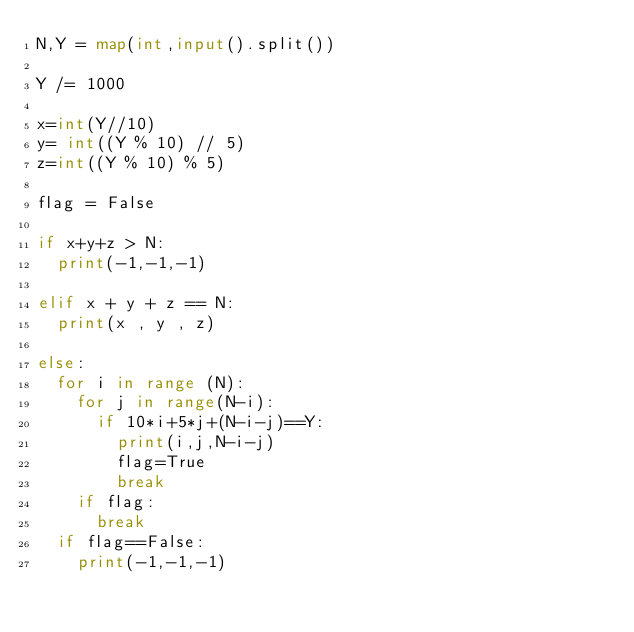Convert code to text. <code><loc_0><loc_0><loc_500><loc_500><_Python_>N,Y = map(int,input().split())

Y /= 1000

x=int(Y//10)
y= int((Y % 10) // 5)
z=int((Y % 10) % 5)

flag = False

if x+y+z > N:
  print(-1,-1,-1)
  
elif x + y + z == N:
  print(x , y , z)
  
else:
  for i in range (N):
    for j in range(N-i):
      if 10*i+5*j+(N-i-j)==Y:
        print(i,j,N-i-j)
        flag=True
        break
    if flag:
      break
  if flag==False:
    print(-1,-1,-1)
  </code> 